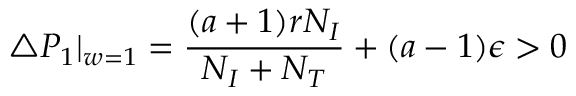<formula> <loc_0><loc_0><loc_500><loc_500>\triangle P _ { 1 } | _ { w = 1 } = \frac { ( a + 1 ) r N _ { I } } { N _ { I } + N _ { T } } + ( a - 1 ) \epsilon > 0</formula> 